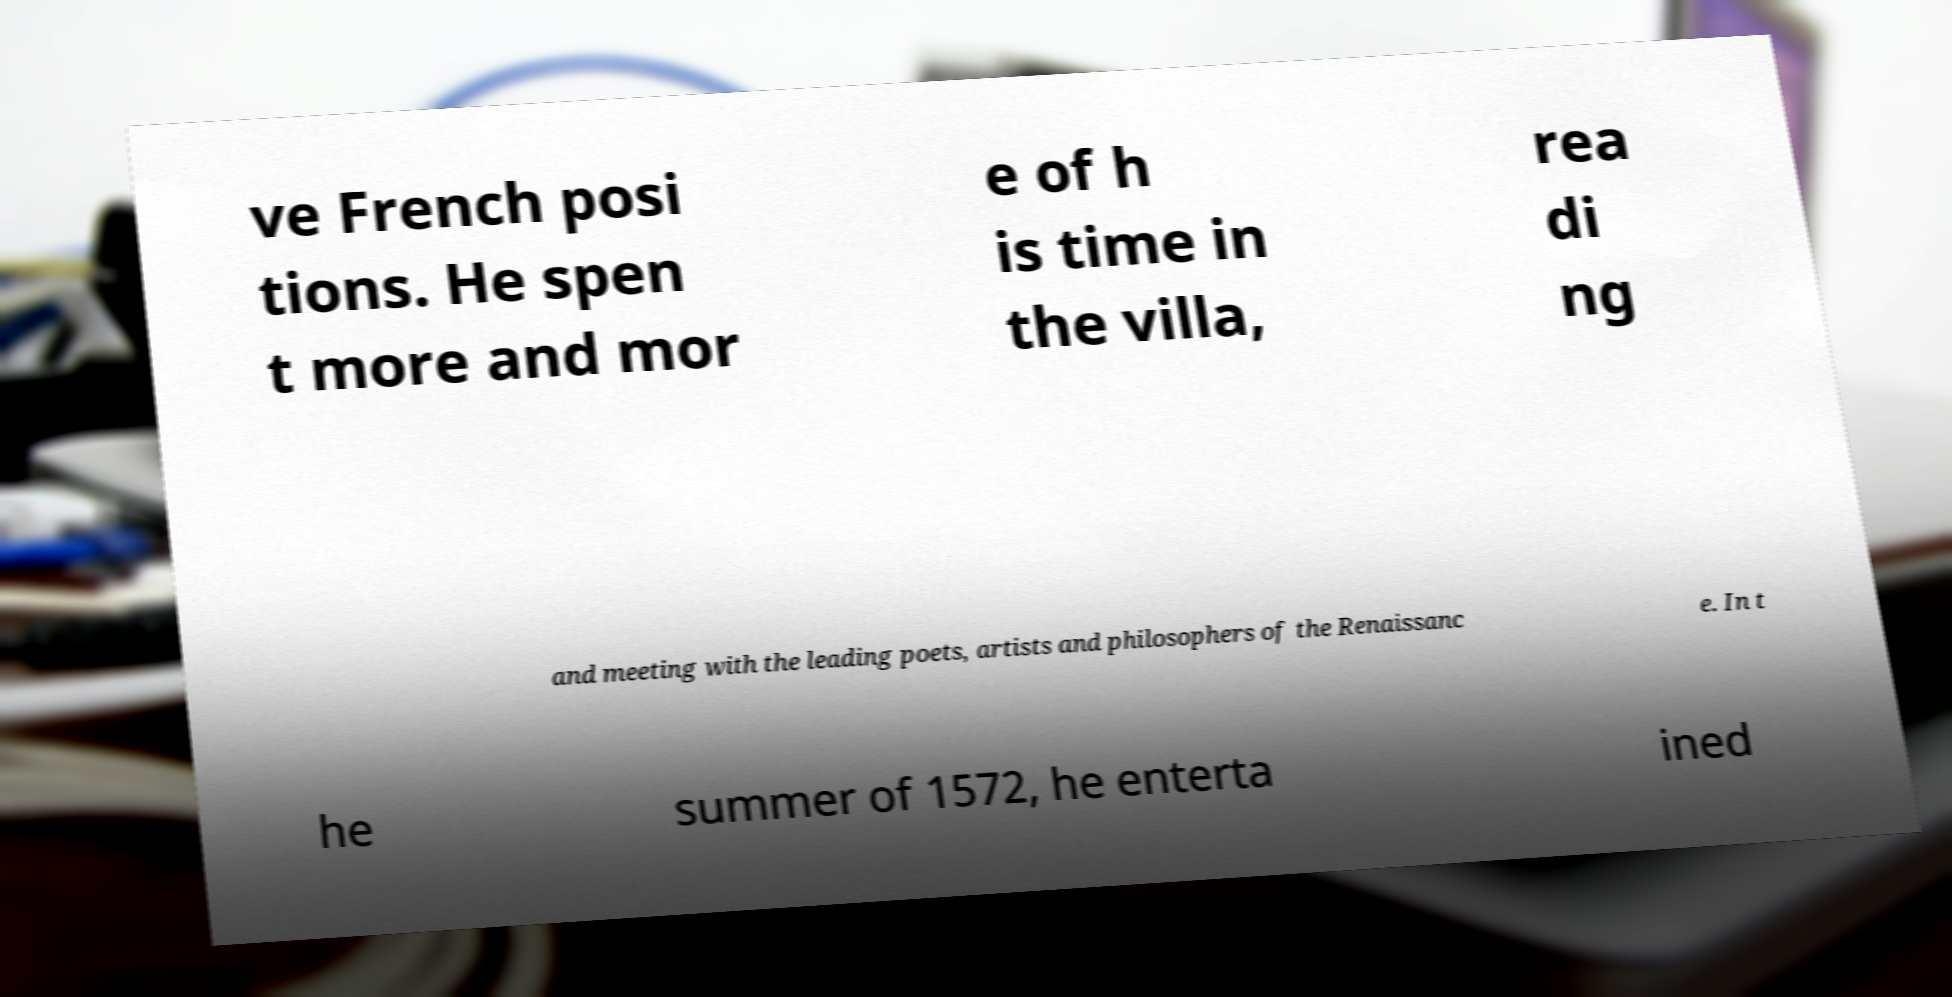Please identify and transcribe the text found in this image. ve French posi tions. He spen t more and mor e of h is time in the villa, rea di ng and meeting with the leading poets, artists and philosophers of the Renaissanc e. In t he summer of 1572, he enterta ined 